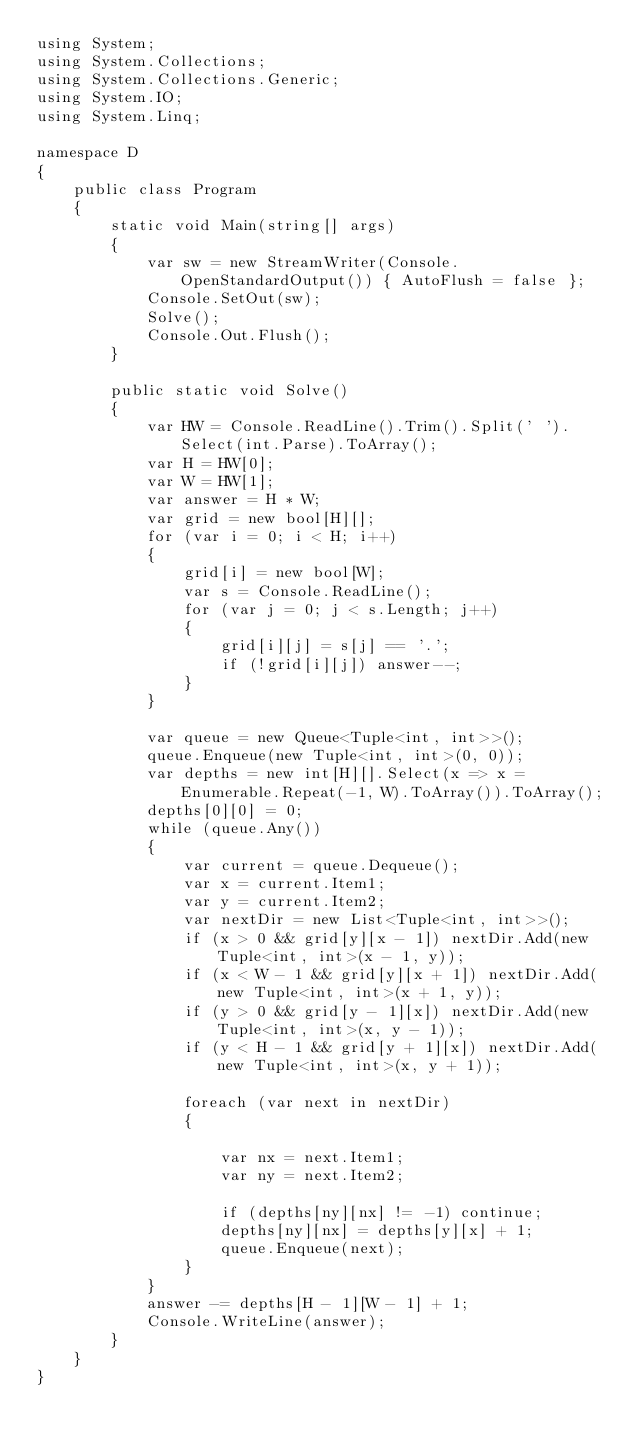<code> <loc_0><loc_0><loc_500><loc_500><_C#_>using System;
using System.Collections;
using System.Collections.Generic;
using System.IO;
using System.Linq;

namespace D
{
    public class Program
    {
        static void Main(string[] args)
        {
            var sw = new StreamWriter(Console.OpenStandardOutput()) { AutoFlush = false };
            Console.SetOut(sw);
            Solve();
            Console.Out.Flush();
        }

        public static void Solve()
        {
            var HW = Console.ReadLine().Trim().Split(' ').Select(int.Parse).ToArray();
            var H = HW[0];
            var W = HW[1];
            var answer = H * W;
            var grid = new bool[H][];
            for (var i = 0; i < H; i++)
            {
                grid[i] = new bool[W];
                var s = Console.ReadLine();
                for (var j = 0; j < s.Length; j++)
                {
                    grid[i][j] = s[j] == '.';
                    if (!grid[i][j]) answer--;
                }
            }
          
            var queue = new Queue<Tuple<int, int>>();
            queue.Enqueue(new Tuple<int, int>(0, 0));
            var depths = new int[H][].Select(x => x = Enumerable.Repeat(-1, W).ToArray()).ToArray();
            depths[0][0] = 0;
            while (queue.Any())
            {
                var current = queue.Dequeue();
                var x = current.Item1;
                var y = current.Item2;
                var nextDir = new List<Tuple<int, int>>();
                if (x > 0 && grid[y][x - 1]) nextDir.Add(new Tuple<int, int>(x - 1, y));
                if (x < W - 1 && grid[y][x + 1]) nextDir.Add(new Tuple<int, int>(x + 1, y));
                if (y > 0 && grid[y - 1][x]) nextDir.Add(new Tuple<int, int>(x, y - 1));
                if (y < H - 1 && grid[y + 1][x]) nextDir.Add(new Tuple<int, int>(x, y + 1));

                foreach (var next in nextDir)
                {

                    var nx = next.Item1;
                    var ny = next.Item2;

                    if (depths[ny][nx] != -1) continue;
                    depths[ny][nx] = depths[y][x] + 1;
                    queue.Enqueue(next);
                }
            }
            answer -= depths[H - 1][W - 1] + 1;
            Console.WriteLine(answer);
        }
    }
}</code> 